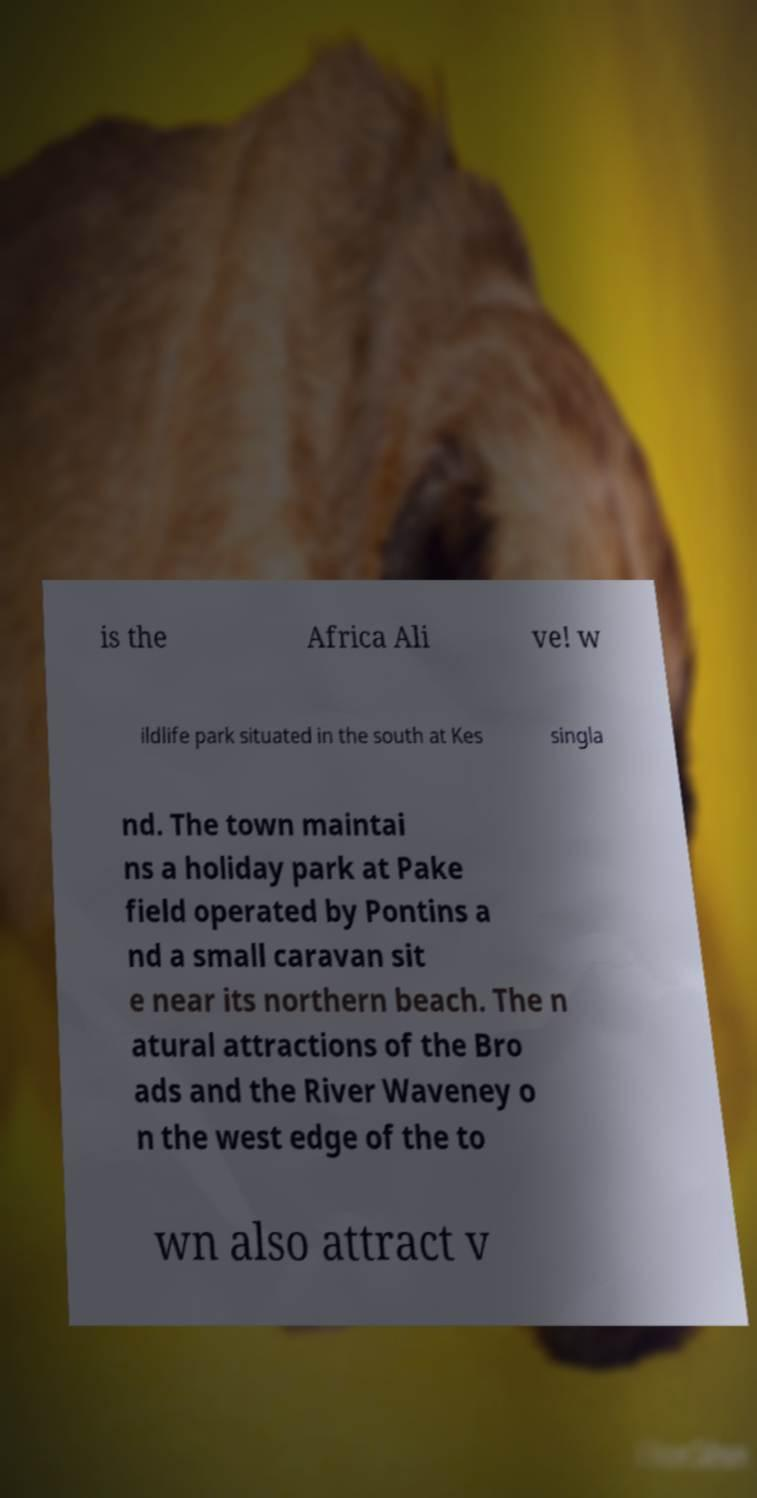I need the written content from this picture converted into text. Can you do that? is the Africa Ali ve! w ildlife park situated in the south at Kes singla nd. The town maintai ns a holiday park at Pake field operated by Pontins a nd a small caravan sit e near its northern beach. The n atural attractions of the Bro ads and the River Waveney o n the west edge of the to wn also attract v 